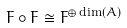<formula> <loc_0><loc_0><loc_500><loc_500>F \circ F \cong F ^ { \oplus \dim ( A ) }</formula> 